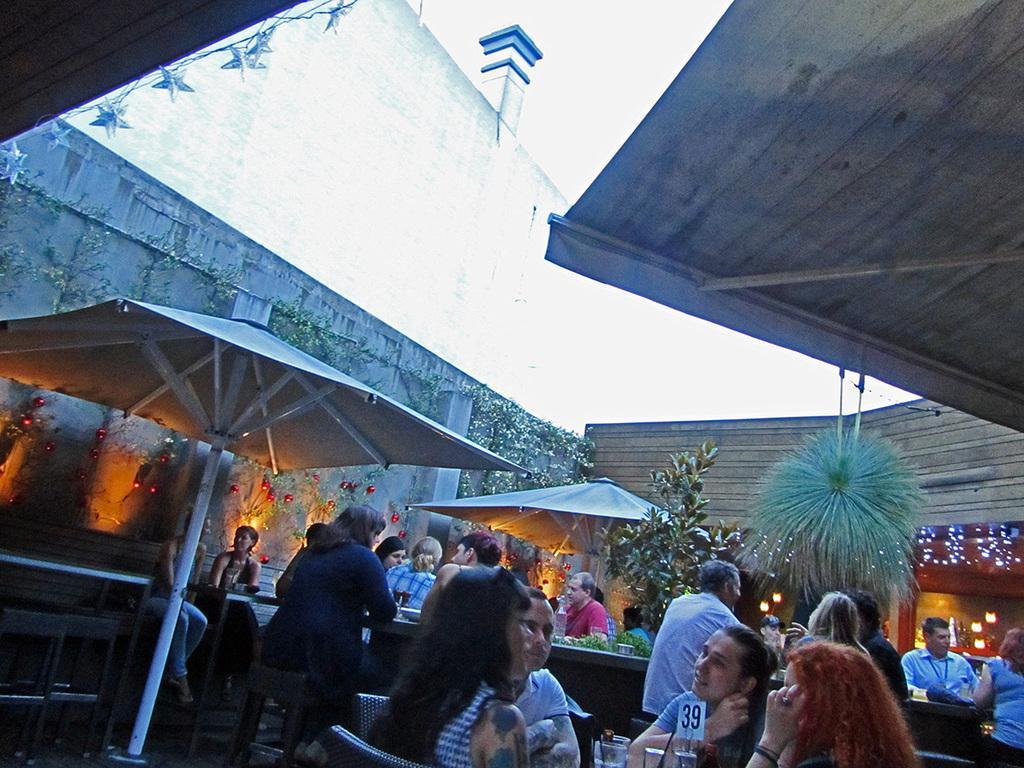Can you describe this image briefly? It is a restaurant many people are sitting in front of the tables and there are some trees in between the tables and the restaurant is beautifully decorated with lights. 